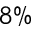<formula> <loc_0><loc_0><loc_500><loc_500>8 \%</formula> 